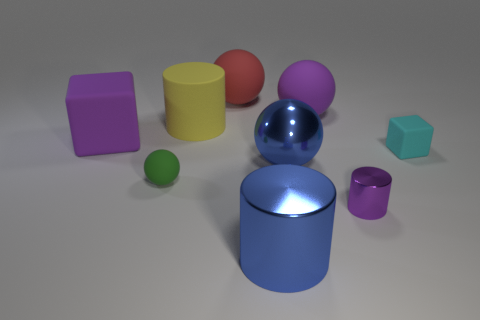Which objects in this image appear to have a reflective surface? The sphere and the cylinder in the center have reflective surfaces that you can notice by the way they cast highlights and reflect light from their environment. 